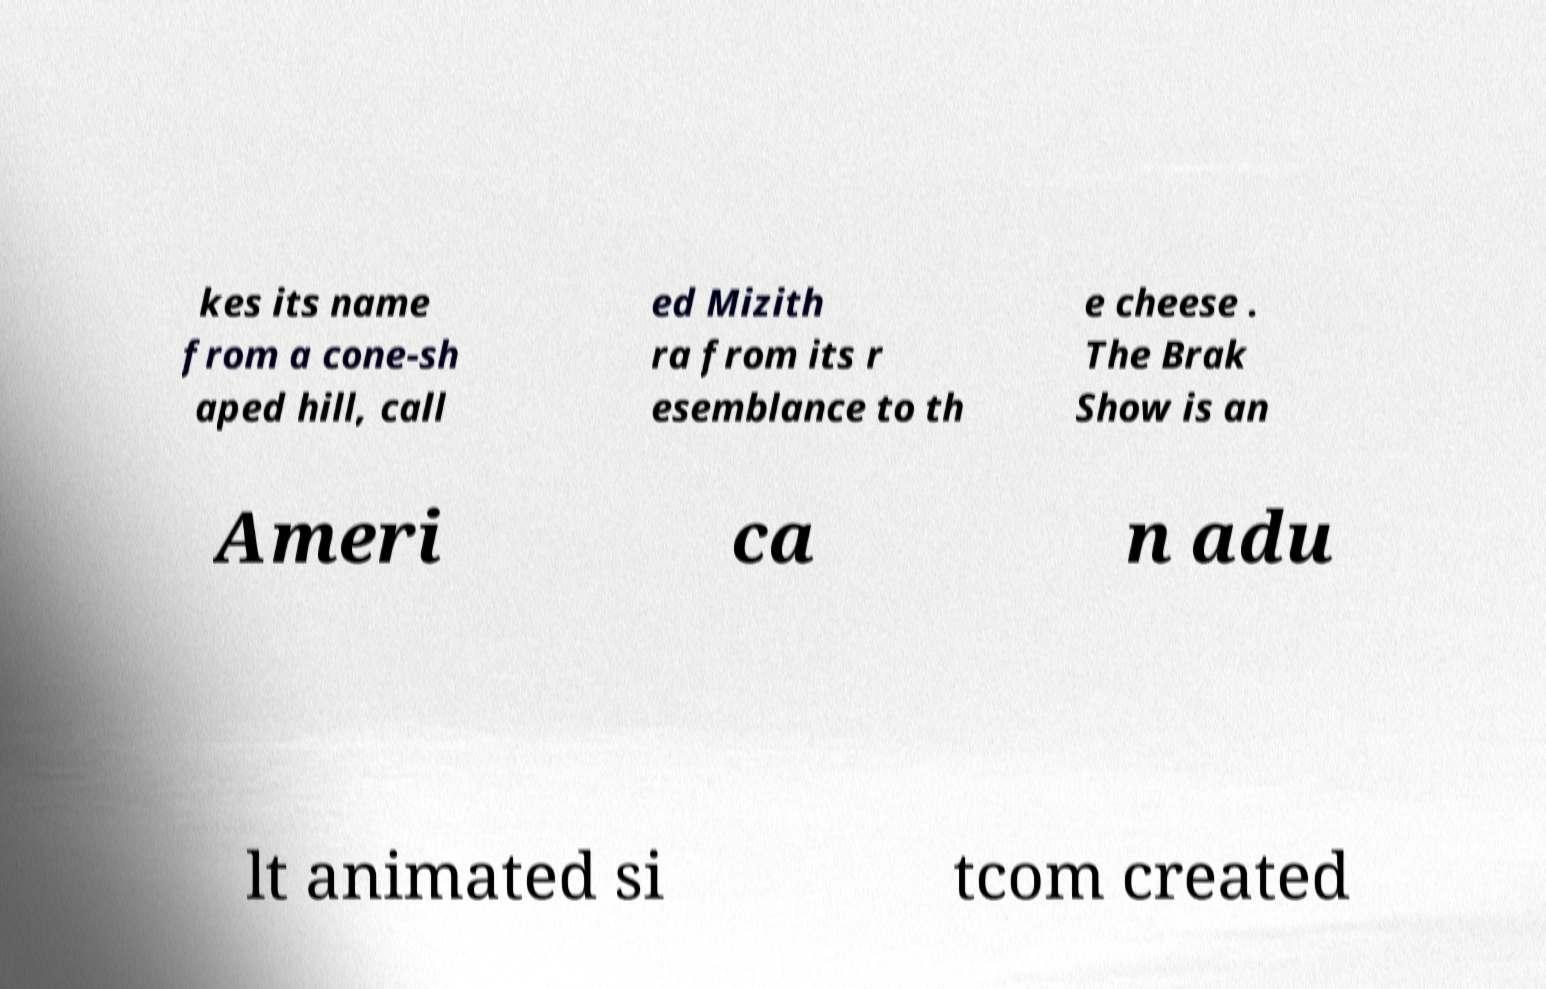Can you accurately transcribe the text from the provided image for me? kes its name from a cone-sh aped hill, call ed Mizith ra from its r esemblance to th e cheese . The Brak Show is an Ameri ca n adu lt animated si tcom created 